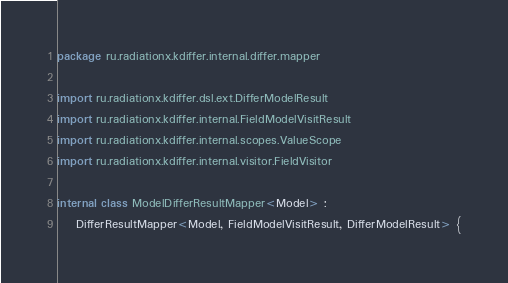Convert code to text. <code><loc_0><loc_0><loc_500><loc_500><_Kotlin_>package ru.radiationx.kdiffer.internal.differ.mapper

import ru.radiationx.kdiffer.dsl.ext.DifferModelResult
import ru.radiationx.kdiffer.internal.FieldModelVisitResult
import ru.radiationx.kdiffer.internal.scopes.ValueScope
import ru.radiationx.kdiffer.internal.visitor.FieldVisitor

internal class ModelDifferResultMapper<Model> :
    DifferResultMapper<Model, FieldModelVisitResult, DifferModelResult> {
</code> 